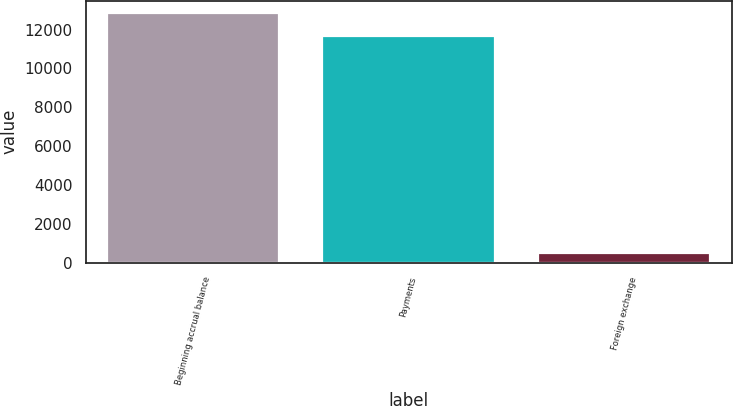<chart> <loc_0><loc_0><loc_500><loc_500><bar_chart><fcel>Beginning accrual balance<fcel>Payments<fcel>Foreign exchange<nl><fcel>12840.1<fcel>11652<fcel>482<nl></chart> 